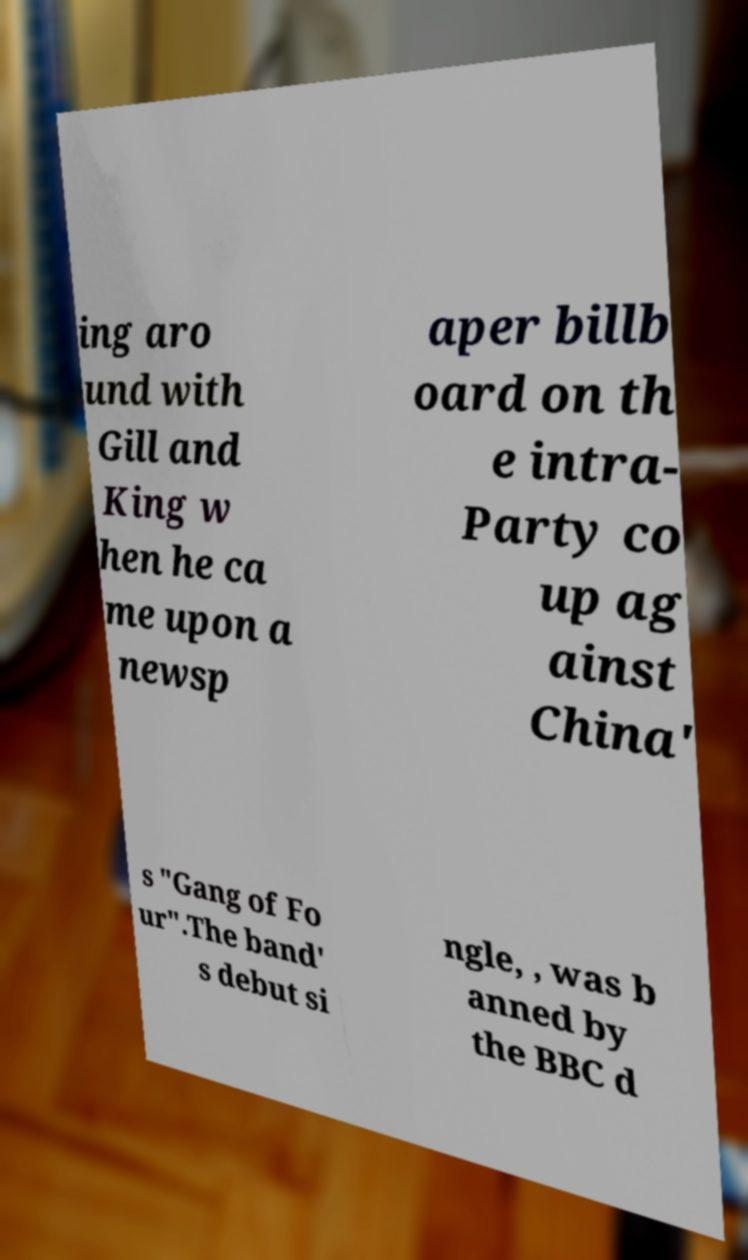For documentation purposes, I need the text within this image transcribed. Could you provide that? ing aro und with Gill and King w hen he ca me upon a newsp aper billb oard on th e intra- Party co up ag ainst China' s "Gang of Fo ur".The band' s debut si ngle, , was b anned by the BBC d 